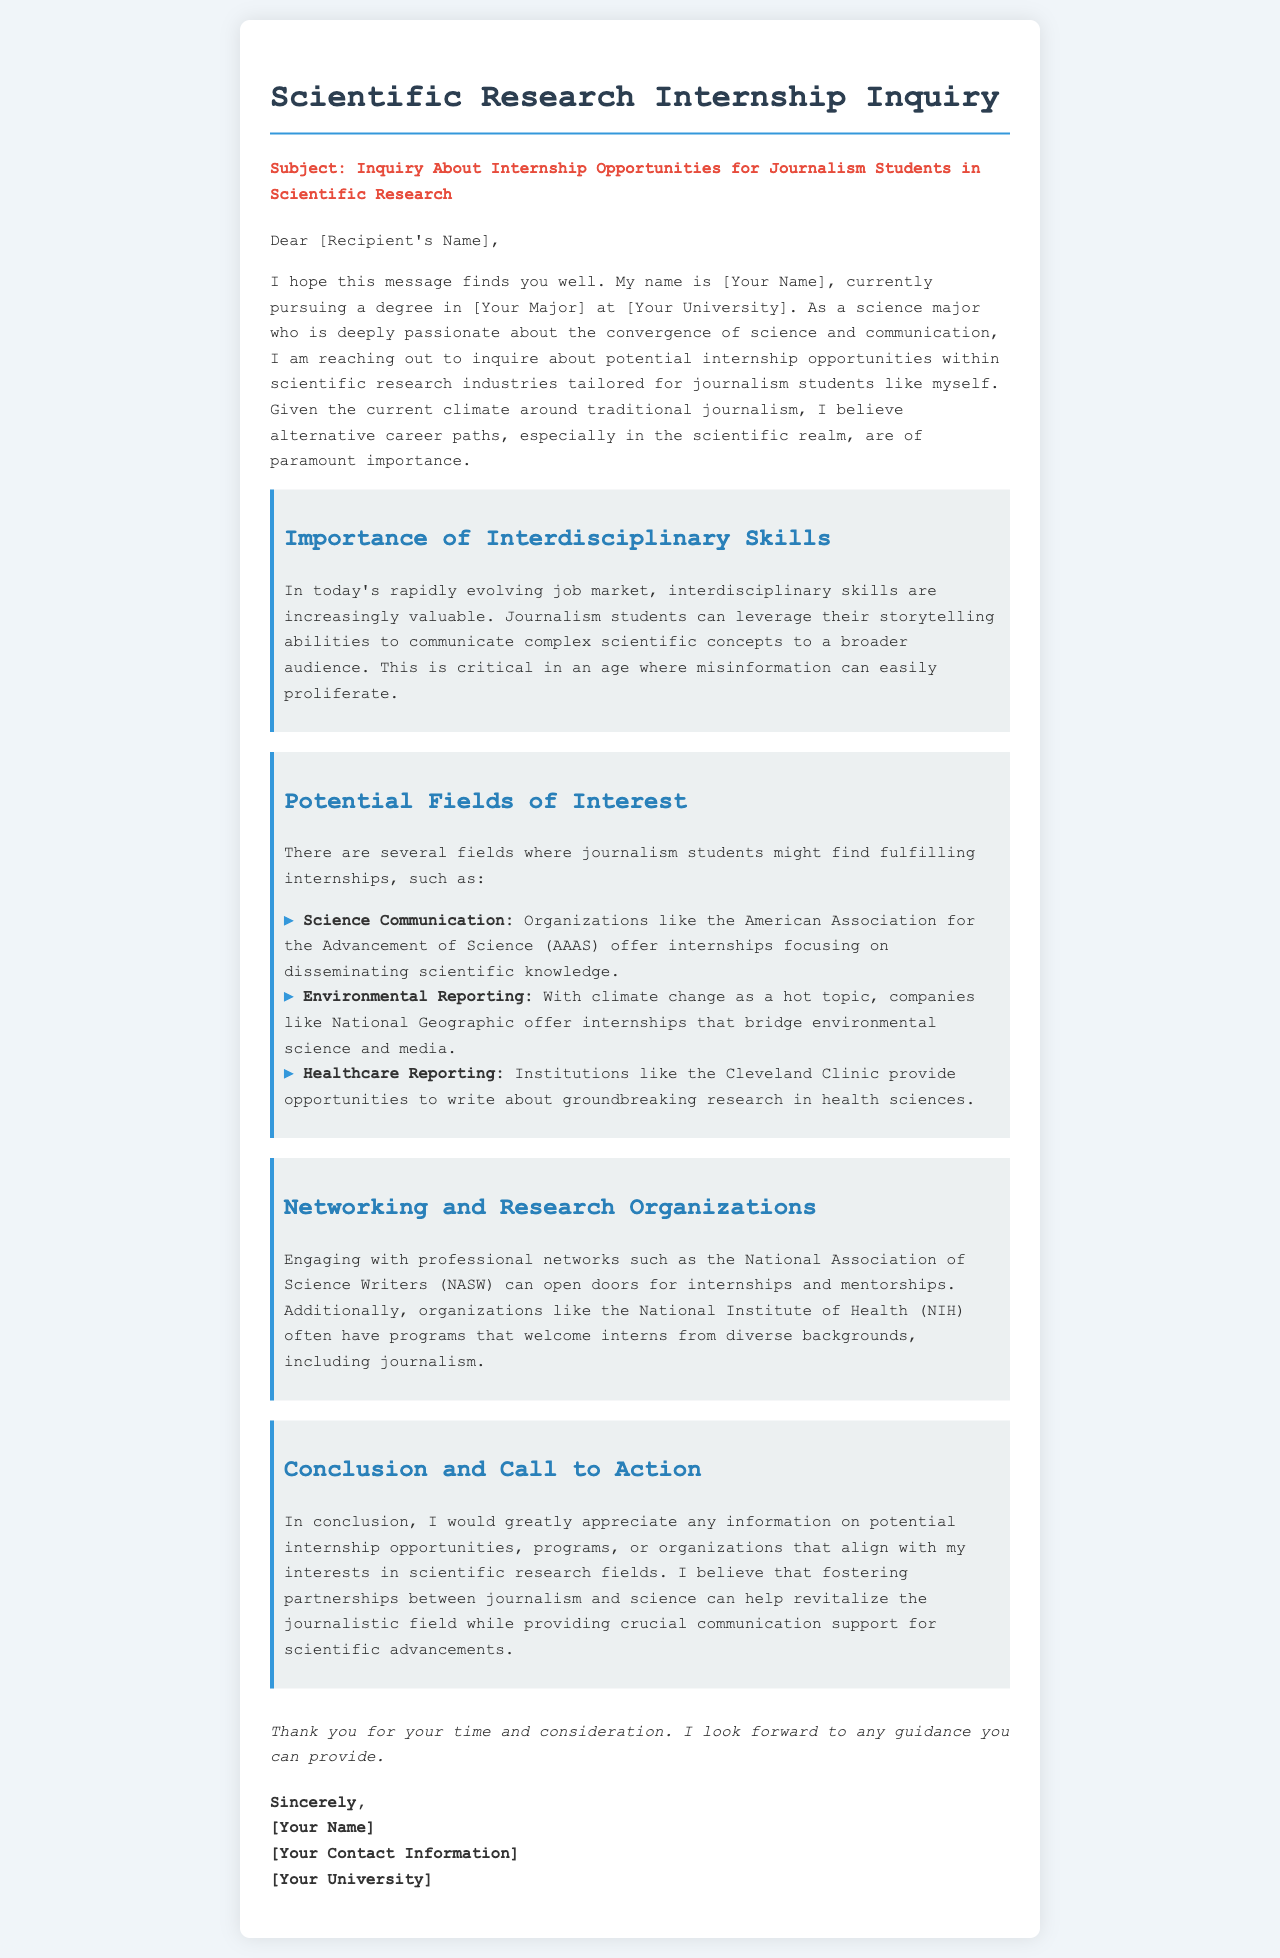What is the subject of the letter? The subject is explicitly stated at the beginning of the letter, highlighting the inquiry about internships.
Answer: Inquiry About Internship Opportunities for Journalism Students in Scientific Research Who is the sender of the letter? The sender is indicated at the end of the letter where the signature is located.
Answer: [Your Name] What organization offers internships in science communication? The letter lists specific organizations in sections discussing fields of interest, particularly for science communication.
Answer: American Association for the Advancement of Science (AAAS) Which professional network is mentioned for networking opportunities? The letter discusses the value of networking and mentions a specific organization for journalists.
Answer: National Association of Science Writers (NASW) What is the target audience of the letter? The introductory section explains the sender's background and purpose for contacting the recipient.
Answer: Journalism students seeking internships in scientific research What is one potential field of interest mentioned? The document explicitly lists various fields where relevant internship opportunities can be found.
Answer: Environmental Reporting Why does the sender believe interdisciplinary skills are valuable? The letter explains the importance of these skills in communicating complex concepts and combating misinformation.
Answer: Because they help communicate complex scientific concepts to a broader audience What call to action is made in the letter? The closing statements outline what the sender is requesting from the recipient concerning internships.
Answer: Information on potential internship opportunities 